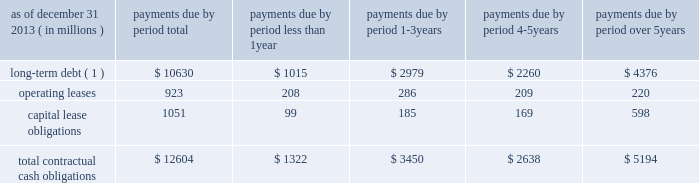Management 2019s discussion and analysis of financial condition and results of operations ( continued ) the npr is generally consistent with the basel committee 2019s lcr .
However , it includes certain more stringent requirements , including an accelerated implementation time line and modifications to the definition of high-quality liquid assets and expected outflow assumptions .
We continue to analyze the proposed rules and analyze their impact as well as develop strategies for compliance .
The principles of the lcr are consistent with our liquidity management framework ; however , the specific calibrations of various elements within the final lcr rule , such as the eligibility of assets as hqla , operational deposit requirements and net outflow requirements could have a material effect on our liquidity , funding and business activities , including the management and composition of our investment securities portfolio and our ability to extend committed contingent credit facilities to our clients .
In january 2014 , the basel committee released a revised proposal with respect to the net stable funding ratio , or nsfr , which will establish a one-year liquidity standard representing the proportion of long-term assets funded by long-term stable funding , scheduled for global implementation in 2018 .
The revised nsfr has made some favorable changes regarding the treatment of operationally linked deposits and a reduction in the funding required for certain securities .
However , we continue to review the specifics of the basel committee's release and will be evaluating the u.s .
Implementation of this standard to analyze the impact and develop strategies for compliance .
U.s .
Banking regulators have not yet issued a proposal to implement the nsfr .
Contractual cash obligations and other commitments the table presents our long-term contractual cash obligations , in total and by period due as of december 31 , 2013 .
These obligations were recorded in our consolidated statement of condition as of that date , except for operating leases and the interest portions of long-term debt and capital leases .
Contractual cash obligations .
( 1 ) long-term debt excludes capital lease obligations ( presented as a separate line item ) and the effect of interest-rate swaps .
Interest payments were calculated at the stated rate with the exception of floating-rate debt , for which payments were calculated using the indexed rate in effect as of december 31 , 2013 .
The table above does not include obligations which will be settled in cash , primarily in less than one year , such as client deposits , federal funds purchased , securities sold under repurchase agreements and other short-term borrowings .
Additional information about deposits , federal funds purchased , securities sold under repurchase agreements and other short-term borrowings is provided in notes 8 and 9 to the consolidated financial statements included under item 8 of this form 10-k .
The table does not include obligations related to derivative instruments because the derivative-related amounts recorded in our consolidated statement of condition as of december 31 , 2013 did not represent the amounts that may ultimately be paid under the contracts upon settlement .
Additional information about our derivative instruments is provided in note 16 to the consolidated financial statements included under item 8 of this form 10-k .
We have obligations under pension and other post-retirement benefit plans , more fully described in note 19 to the consolidated financial statements included under item 8 of this form 10-k , which are not included in the above table .
Additional information about contractual cash obligations related to long-term debt and operating and capital leases is provided in notes 10 and 20 to the consolidated financial statements included under item 8 of this form 10-k .
Our consolidated statement of cash flows , also included under item 8 of this form 10-k , provides additional liquidity information .
The following table presents our commitments , other than the contractual cash obligations presented above , in total and by duration as of december 31 , 2013 .
These commitments were not recorded in our consolidated statement of condition as of that date. .
What percent of total contractual obligations has been differed over 5 years? 
Computations: (5194 / 12604)
Answer: 0.41209. Management 2019s discussion and analysis of financial condition and results of operations ( continued ) the npr is generally consistent with the basel committee 2019s lcr .
However , it includes certain more stringent requirements , including an accelerated implementation time line and modifications to the definition of high-quality liquid assets and expected outflow assumptions .
We continue to analyze the proposed rules and analyze their impact as well as develop strategies for compliance .
The principles of the lcr are consistent with our liquidity management framework ; however , the specific calibrations of various elements within the final lcr rule , such as the eligibility of assets as hqla , operational deposit requirements and net outflow requirements could have a material effect on our liquidity , funding and business activities , including the management and composition of our investment securities portfolio and our ability to extend committed contingent credit facilities to our clients .
In january 2014 , the basel committee released a revised proposal with respect to the net stable funding ratio , or nsfr , which will establish a one-year liquidity standard representing the proportion of long-term assets funded by long-term stable funding , scheduled for global implementation in 2018 .
The revised nsfr has made some favorable changes regarding the treatment of operationally linked deposits and a reduction in the funding required for certain securities .
However , we continue to review the specifics of the basel committee's release and will be evaluating the u.s .
Implementation of this standard to analyze the impact and develop strategies for compliance .
U.s .
Banking regulators have not yet issued a proposal to implement the nsfr .
Contractual cash obligations and other commitments the table presents our long-term contractual cash obligations , in total and by period due as of december 31 , 2013 .
These obligations were recorded in our consolidated statement of condition as of that date , except for operating leases and the interest portions of long-term debt and capital leases .
Contractual cash obligations .
( 1 ) long-term debt excludes capital lease obligations ( presented as a separate line item ) and the effect of interest-rate swaps .
Interest payments were calculated at the stated rate with the exception of floating-rate debt , for which payments were calculated using the indexed rate in effect as of december 31 , 2013 .
The table above does not include obligations which will be settled in cash , primarily in less than one year , such as client deposits , federal funds purchased , securities sold under repurchase agreements and other short-term borrowings .
Additional information about deposits , federal funds purchased , securities sold under repurchase agreements and other short-term borrowings is provided in notes 8 and 9 to the consolidated financial statements included under item 8 of this form 10-k .
The table does not include obligations related to derivative instruments because the derivative-related amounts recorded in our consolidated statement of condition as of december 31 , 2013 did not represent the amounts that may ultimately be paid under the contracts upon settlement .
Additional information about our derivative instruments is provided in note 16 to the consolidated financial statements included under item 8 of this form 10-k .
We have obligations under pension and other post-retirement benefit plans , more fully described in note 19 to the consolidated financial statements included under item 8 of this form 10-k , which are not included in the above table .
Additional information about contractual cash obligations related to long-term debt and operating and capital leases is provided in notes 10 and 20 to the consolidated financial statements included under item 8 of this form 10-k .
Our consolidated statement of cash flows , also included under item 8 of this form 10-k , provides additional liquidity information .
The following table presents our commitments , other than the contractual cash obligations presented above , in total and by duration as of december 31 , 2013 .
These commitments were not recorded in our consolidated statement of condition as of that date. .
What portion of the long-term debt is reported under the current liabilities section as of december 31 , 2013? 
Computations: (1015 / 10630)
Answer: 0.09548. 